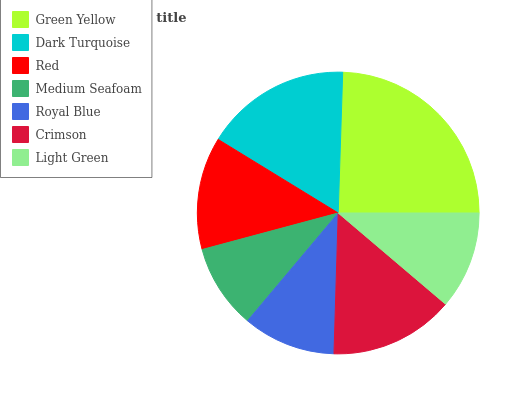Is Medium Seafoam the minimum?
Answer yes or no. Yes. Is Green Yellow the maximum?
Answer yes or no. Yes. Is Dark Turquoise the minimum?
Answer yes or no. No. Is Dark Turquoise the maximum?
Answer yes or no. No. Is Green Yellow greater than Dark Turquoise?
Answer yes or no. Yes. Is Dark Turquoise less than Green Yellow?
Answer yes or no. Yes. Is Dark Turquoise greater than Green Yellow?
Answer yes or no. No. Is Green Yellow less than Dark Turquoise?
Answer yes or no. No. Is Red the high median?
Answer yes or no. Yes. Is Red the low median?
Answer yes or no. Yes. Is Medium Seafoam the high median?
Answer yes or no. No. Is Light Green the low median?
Answer yes or no. No. 